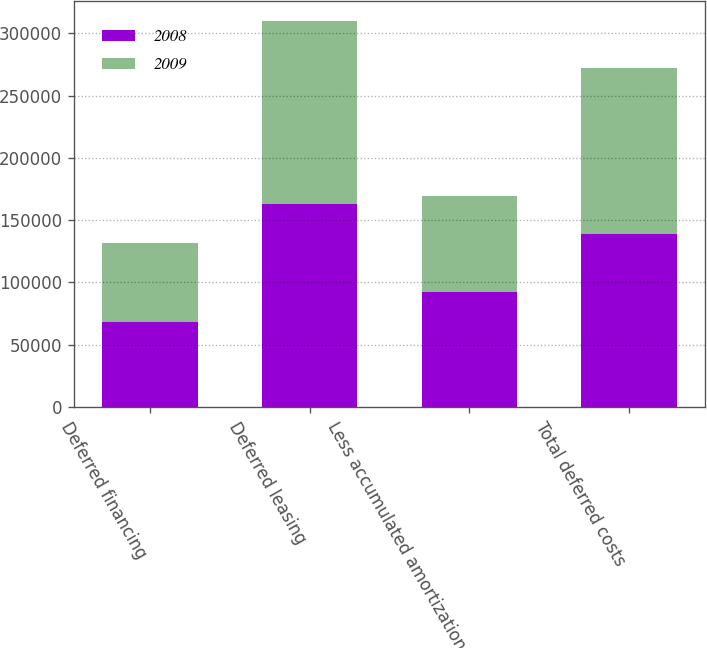Convert chart to OTSL. <chart><loc_0><loc_0><loc_500><loc_500><stacked_bar_chart><ecel><fcel>Deferred financing<fcel>Deferred leasing<fcel>Less accumulated amortization<fcel>Total deferred costs<nl><fcel>2008<fcel>68181<fcel>163372<fcel>92296<fcel>139257<nl><fcel>2009<fcel>63262<fcel>146951<fcel>77161<fcel>133052<nl></chart> 